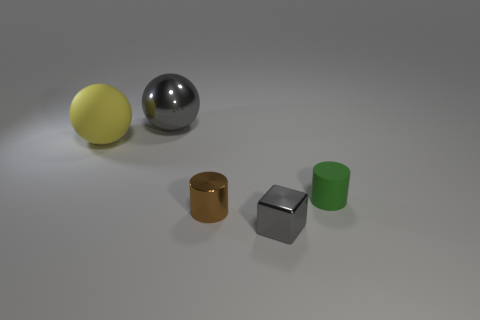The big object that is on the left side of the ball to the right of the big matte ball is made of what material?
Your answer should be very brief. Rubber. There is a object that is both behind the small matte cylinder and in front of the large gray object; what is its material?
Ensure brevity in your answer.  Rubber. Are there any other shiny things of the same shape as the large metallic object?
Your answer should be very brief. No. There is a cylinder that is to the right of the tiny gray object; is there a tiny metallic object that is right of it?
Provide a succinct answer. No. How many tiny brown cylinders are made of the same material as the gray cube?
Provide a succinct answer. 1. Is there a tiny gray block?
Offer a very short reply. Yes. How many large balls have the same color as the tiny metal cube?
Provide a succinct answer. 1. Are the tiny gray cube and the cylinder that is to the left of the gray block made of the same material?
Keep it short and to the point. Yes. Is the number of tiny cylinders on the left side of the small brown metallic thing greater than the number of yellow spheres?
Make the answer very short. No. Are there any other things that have the same size as the yellow thing?
Give a very brief answer. Yes. 